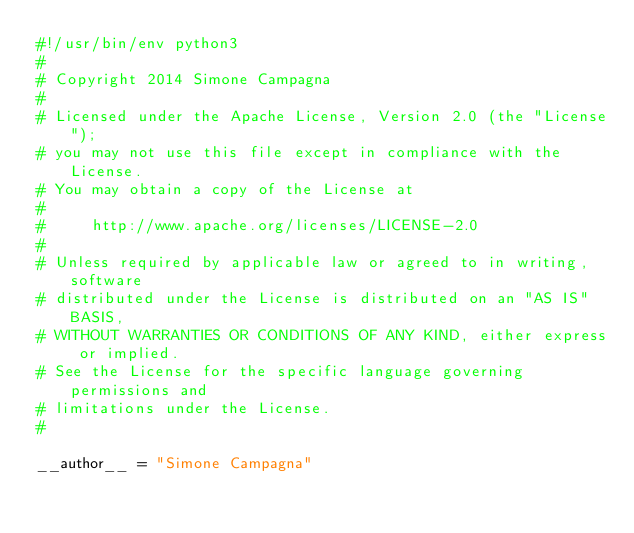<code> <loc_0><loc_0><loc_500><loc_500><_Python_>#!/usr/bin/env python3
#
# Copyright 2014 Simone Campagna
#
# Licensed under the Apache License, Version 2.0 (the "License");
# you may not use this file except in compliance with the License.
# You may obtain a copy of the License at
#
#     http://www.apache.org/licenses/LICENSE-2.0
#
# Unless required by applicable law or agreed to in writing, software
# distributed under the License is distributed on an "AS IS" BASIS,
# WITHOUT WARRANTIES OR CONDITIONS OF ANY KIND, either express or implied.
# See the License for the specific language governing permissions and
# limitations under the License.
#

__author__ = "Simone Campagna"
</code> 